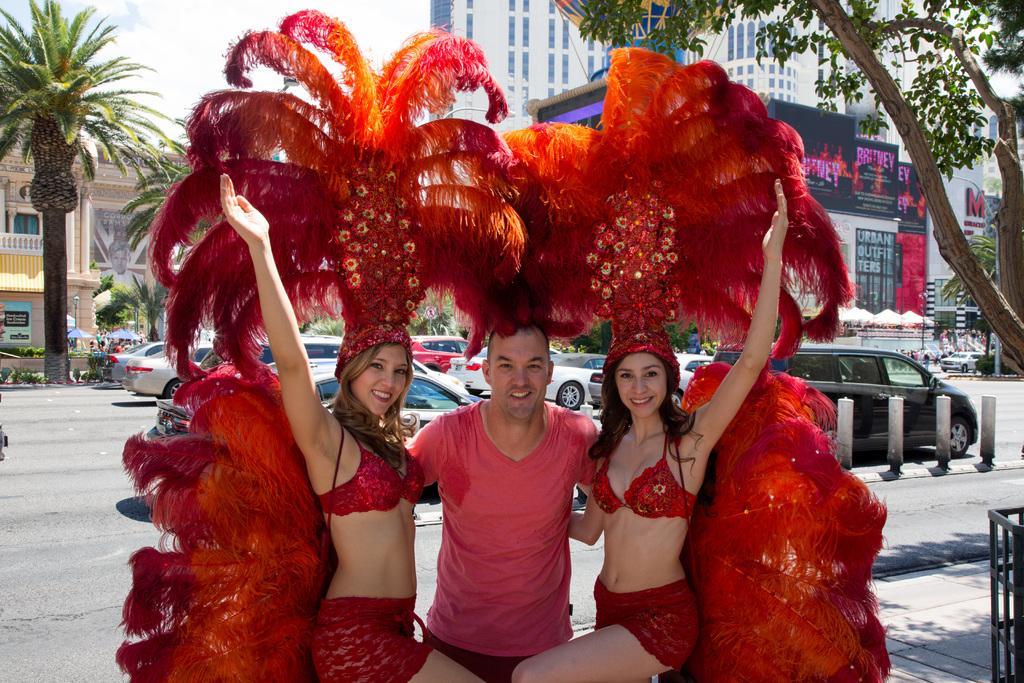Please provide a concise description of this image. In this image there is a man with two women in red costume. In the background there are buildings and trees. There are also cars on the road. Fence and small construction poles are also visible. There is a cloudy sky. 